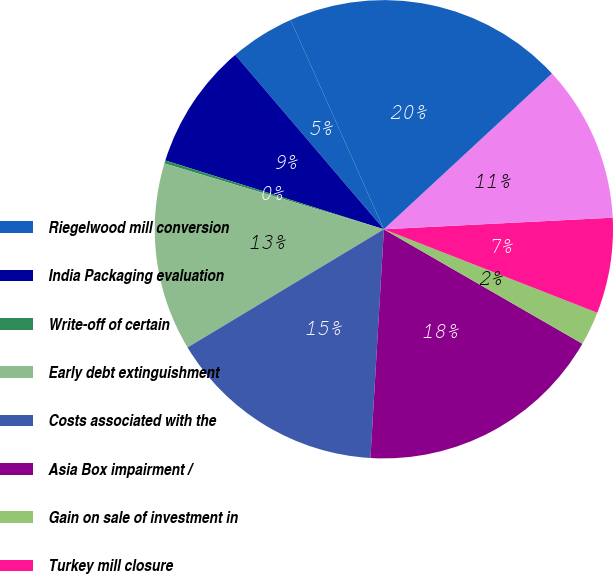Convert chart. <chart><loc_0><loc_0><loc_500><loc_500><pie_chart><fcel>Riegelwood mill conversion<fcel>India Packaging evaluation<fcel>Write-off of certain<fcel>Early debt extinguishment<fcel>Costs associated with the<fcel>Asia Box impairment /<fcel>Gain on sale of investment in<fcel>Turkey mill closure<fcel>Amortization of Weyerhaeuser<fcel>Total special items<nl><fcel>4.56%<fcel>8.91%<fcel>0.22%<fcel>13.26%<fcel>15.44%<fcel>17.61%<fcel>2.39%<fcel>6.74%<fcel>11.09%<fcel>19.78%<nl></chart> 